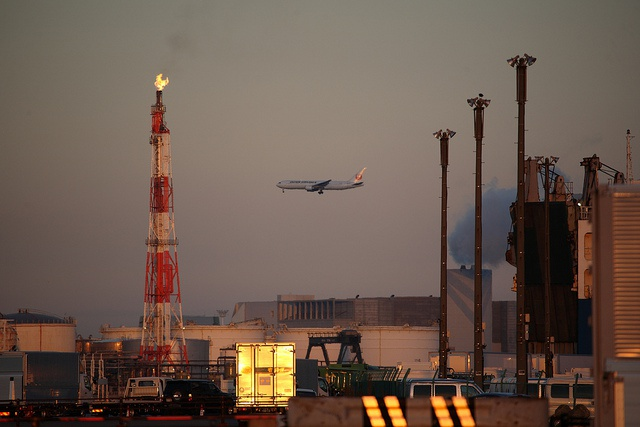Describe the objects in this image and their specific colors. I can see truck in gray, gold, orange, maroon, and black tones, car in gray, black, maroon, and salmon tones, car in gray, black, and maroon tones, airplane in gray and black tones, and car in gray, black, maroon, and brown tones in this image. 